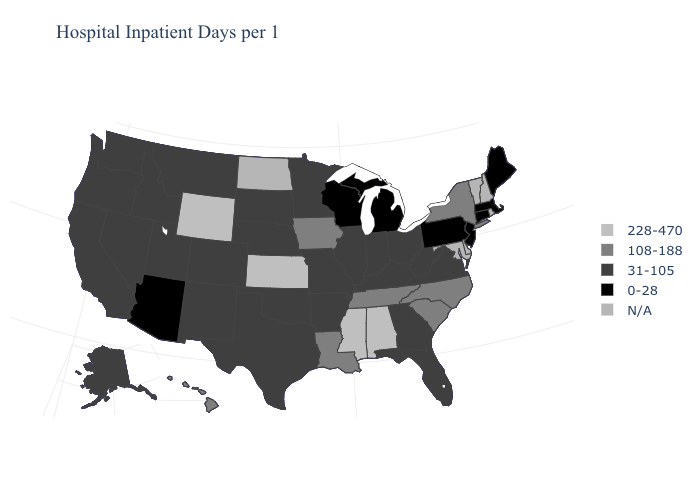Which states hav the highest value in the South?
Quick response, please. Alabama, Mississippi. What is the value of Hawaii?
Keep it brief. 108-188. Name the states that have a value in the range 108-188?
Give a very brief answer. Hawaii, Iowa, Louisiana, New York, North Carolina, South Carolina, Tennessee. Does Wyoming have the highest value in the USA?
Answer briefly. Yes. What is the value of Mississippi?
Answer briefly. 228-470. Does Wyoming have the highest value in the West?
Be succinct. Yes. Which states hav the highest value in the Northeast?
Write a very short answer. New York. How many symbols are there in the legend?
Quick response, please. 5. What is the value of Iowa?
Give a very brief answer. 108-188. What is the lowest value in the Northeast?
Quick response, please. 0-28. Name the states that have a value in the range 31-105?
Keep it brief. Alaska, Arkansas, California, Colorado, Florida, Georgia, Idaho, Illinois, Indiana, Kentucky, Minnesota, Missouri, Montana, Nebraska, Nevada, New Mexico, Ohio, Oklahoma, Oregon, South Dakota, Texas, Utah, Virginia, Washington, West Virginia. What is the highest value in the MidWest ?
Answer briefly. 228-470. Does Indiana have the lowest value in the MidWest?
Give a very brief answer. No. What is the highest value in the South ?
Be succinct. 228-470. 